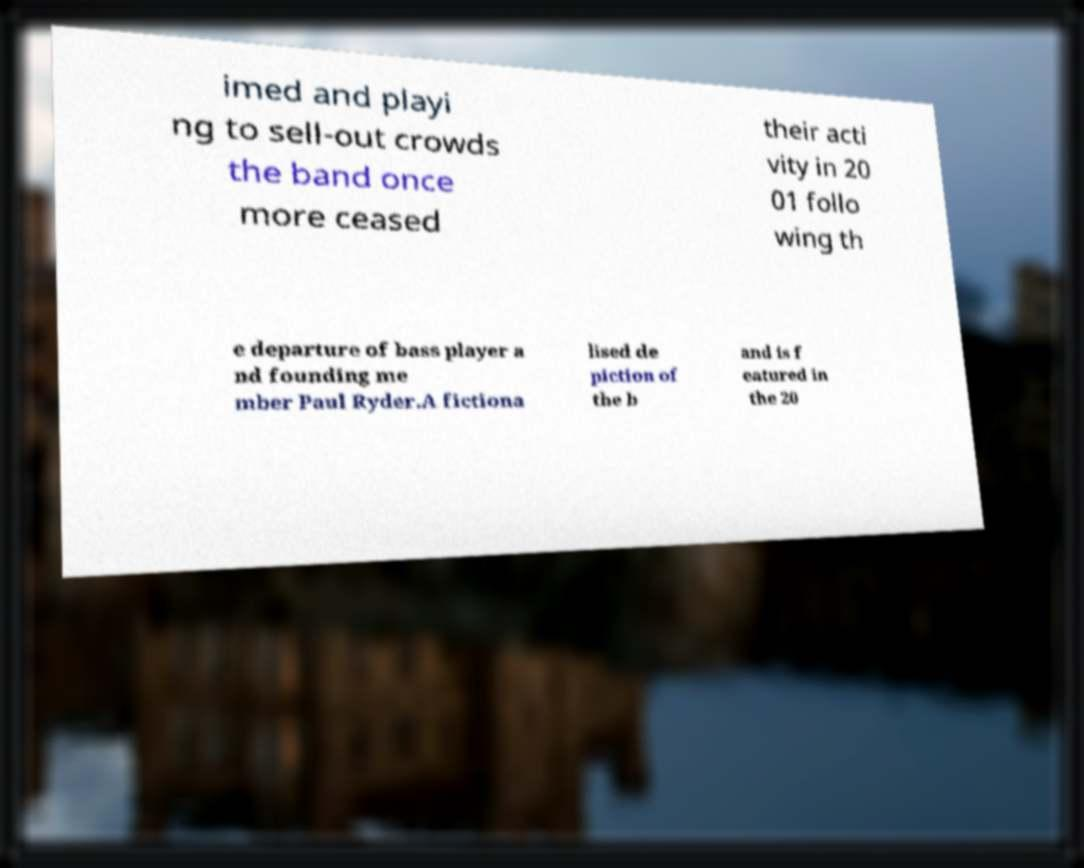For documentation purposes, I need the text within this image transcribed. Could you provide that? imed and playi ng to sell-out crowds the band once more ceased their acti vity in 20 01 follo wing th e departure of bass player a nd founding me mber Paul Ryder.A fictiona lised de piction of the b and is f eatured in the 20 